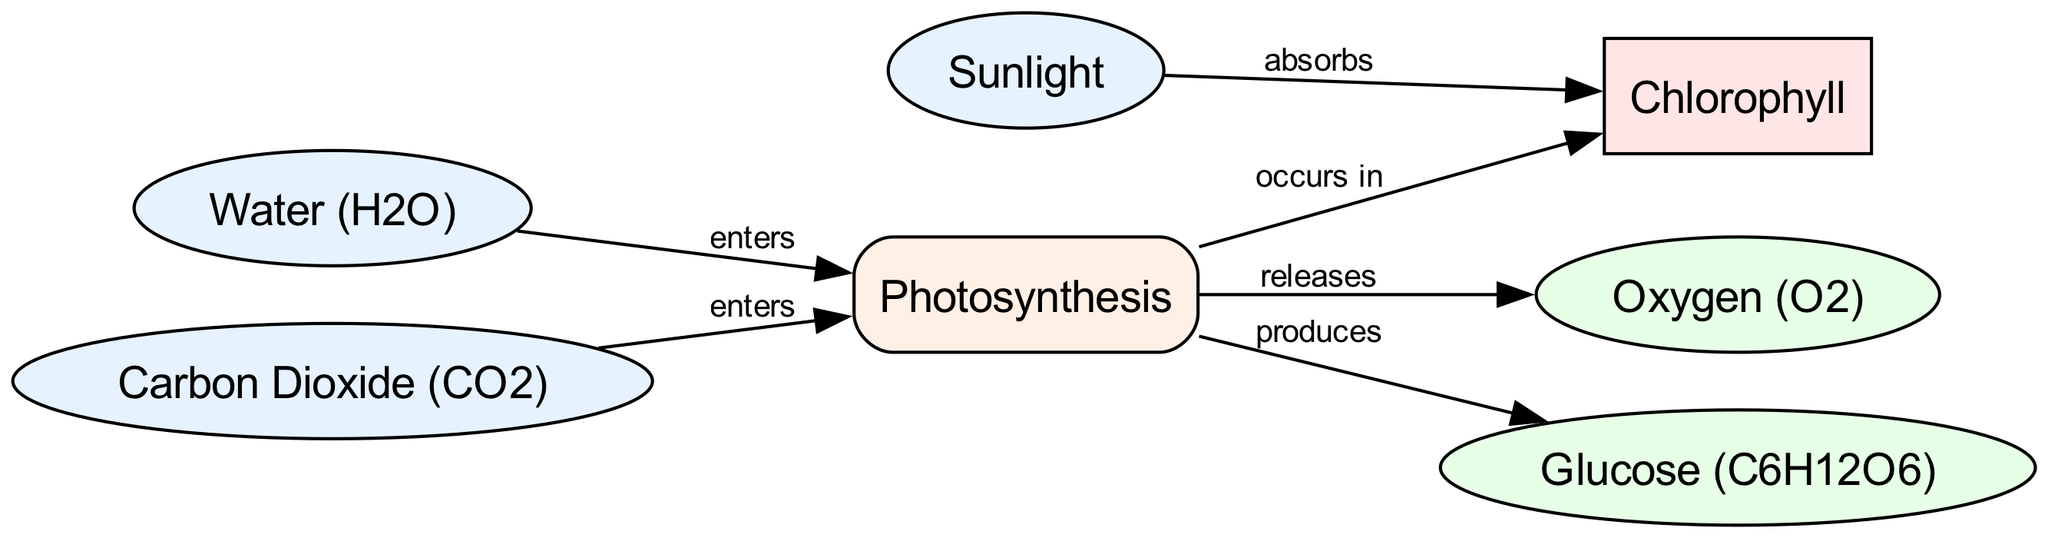What is the input for the photosynthesis process? The inputs for the photosynthesis process, as represented in the diagram, are water and carbon dioxide. Both these nodes are directed to the process of photosynthesis.
Answer: Water and carbon dioxide How many total nodes are there in the diagram? The diagram contains six nodes: sunlight, chlorophyll, water, carbon dioxide, oxygen, and glucose. Therefore, we count these nodes to find the total number.
Answer: Six What does chlorophyll do with sunlight? According to the diagram, chlorophyll absorbs sunlight, which is indicated by the edge connecting sunlight to chlorophyll with the label 'absorbs'.
Answer: Absorbs What is produced as an output in photosynthesis? The outputs of the photosynthesis process, as shown in the diagram, are oxygen and glucose. Both nodes are connected to the photosynthesis process with the labels 'releases' and 'produces' respectively.
Answer: Oxygen and glucose Which two substances enter the photosynthesis process? The substances that enter the photosynthesis process are water and carbon dioxide, as indicated by the edges pointing to the photosynthesis node from both the water and carbon dioxide nodes.
Answer: Water and carbon dioxide What role does chlorophyll play in the photosynthesis process? Chlorophyll occurs in the photosynthesis process, which is represented by the edge labeled 'occurs in' connecting the photosynthesis node to chlorophyll. Therefore, chlorophyll is integral to the process itself.
Answer: Integral component How many outputs are produced from the photosynthesis process? The diagram shows two outputs from the photosynthesis process, which are oxygen and glucose, hence we count these outputs to determine the answer.
Answer: Two What is the relationship between water and chlorophyll in this diagram? There is no direct relationship between water and chlorophyll in this diagram. Water enters the photosynthesis process, while chlorophyll absorbs sunlight and occurs in the process. The indirect relationship is established through the photosynthesis node.
Answer: Indirect relationship What type of process is photosynthesis? Photosynthesis is classified as a process in the diagram. It is depicted as a rectangle, distinguishing it from the input and output nodes.
Answer: Process 